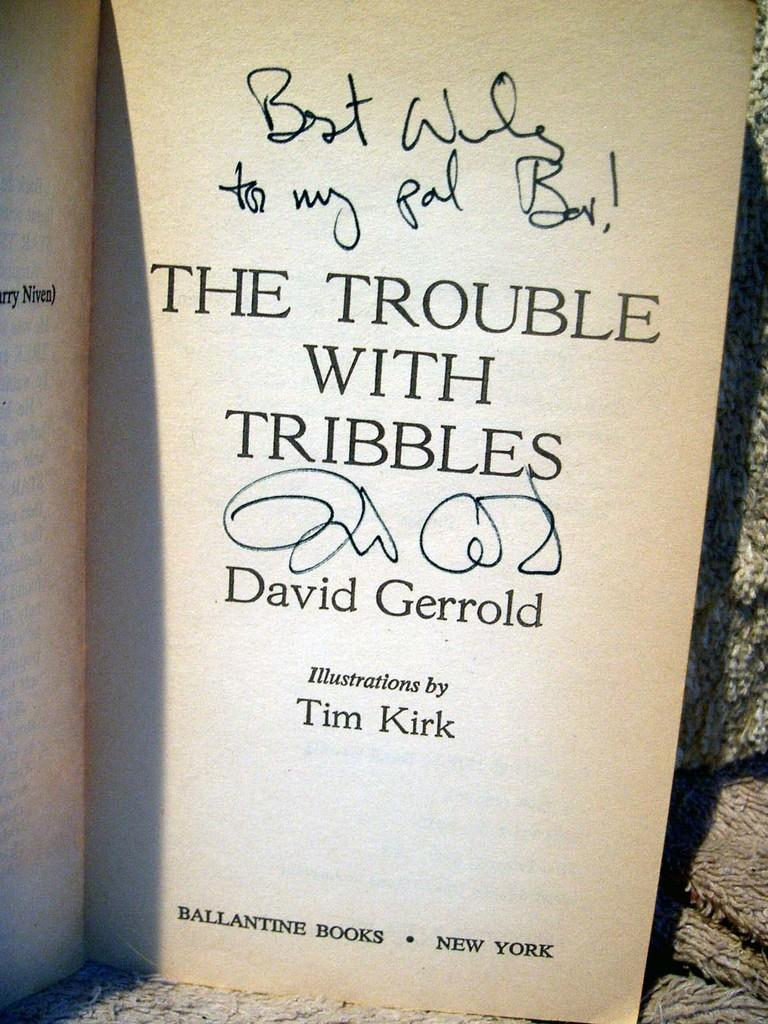Provide a one-sentence caption for the provided image. David Gerrold signed a copy of his book, "The Trouble with Tribbles.". 